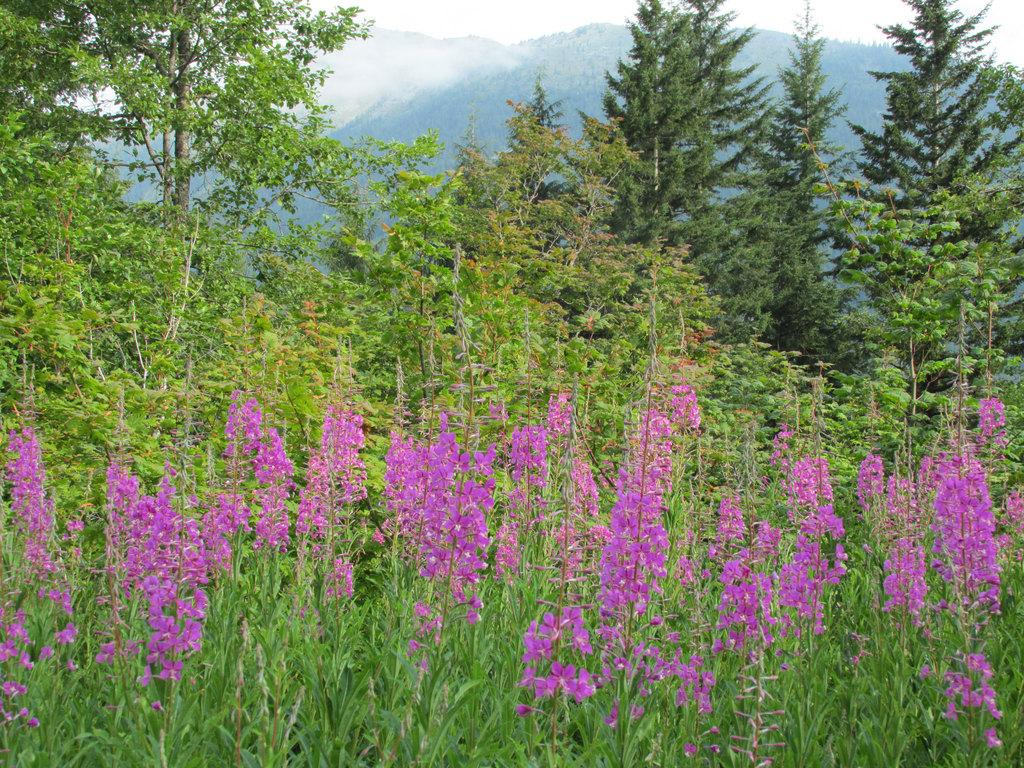What types of vegetation can be seen in the image? There are plants and flowers in the image. What can be seen in the background of the image? There are mountains, trees, and fog in the background of the image. What type of silverware is visible in the image? There is no silverware present in the image; it features plants, flowers, mountains, trees, and fog. 